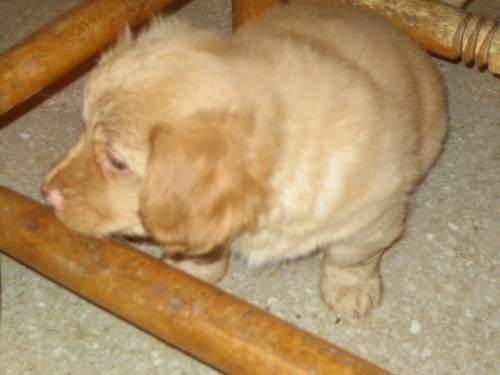Can you describe the mood or atmosphere conveyed by the image? The image gives off a warm and calm atmosphere, likely due to the soft, gentle appearance of the puppy that's the main subject. The warm color tone and intimate setting add to the cozy and serene vibe of the scene. 